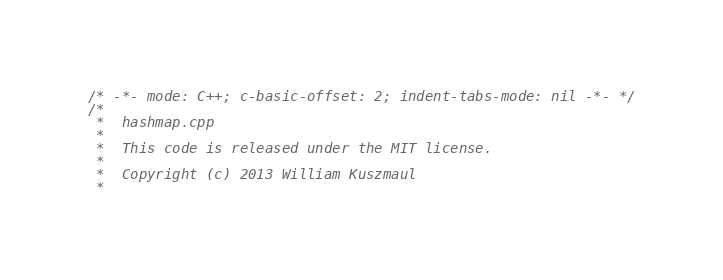Convert code to text. <code><loc_0><loc_0><loc_500><loc_500><_C++_>/* -*- mode: C++; c-basic-offset: 2; indent-tabs-mode: nil -*- */
/*
 *  hashmap.cpp
 *
 *  This code is released under the MIT license.
 * 
 *  Copyright (c) 2013 William Kuszmaul
 *  </code> 